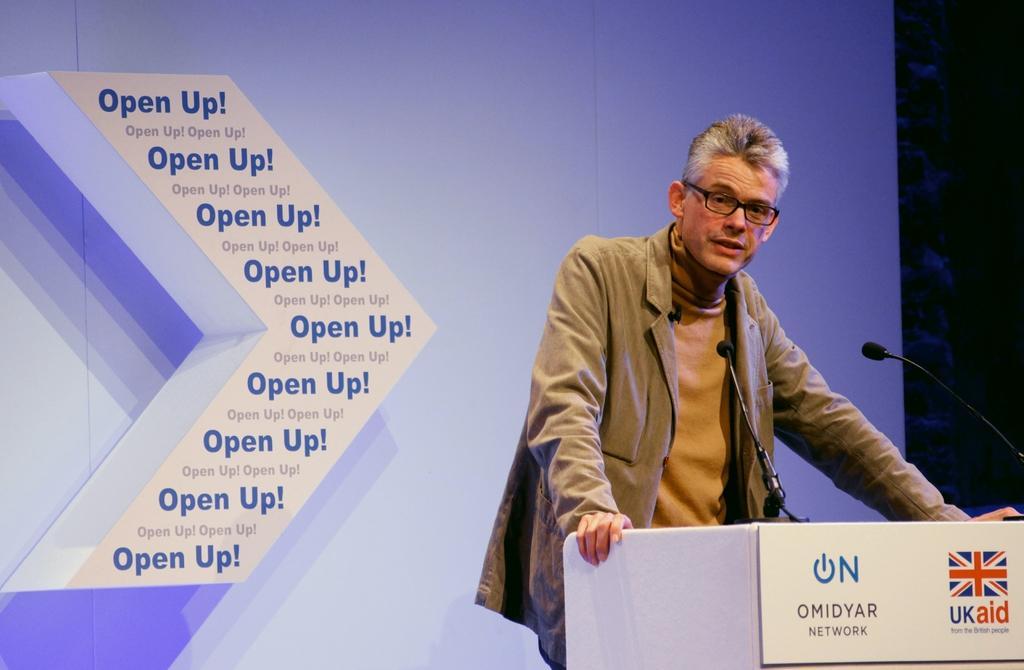In one or two sentences, can you explain what this image depicts? In the picture we can see a person wearing brown color jacket, also wearing spectacles standing behind podium on which there are some microphones, there is some board attached and in the background of the picture there is blue color sheet and some words written. 